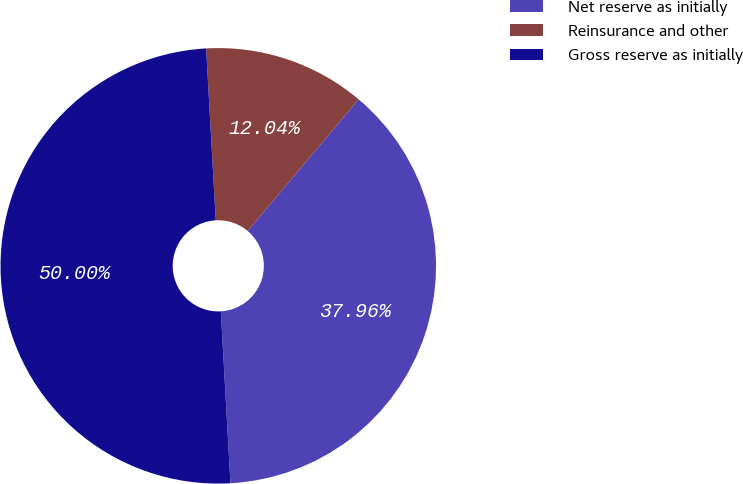Convert chart to OTSL. <chart><loc_0><loc_0><loc_500><loc_500><pie_chart><fcel>Net reserve as initially<fcel>Reinsurance and other<fcel>Gross reserve as initially<nl><fcel>37.96%<fcel>12.04%<fcel>50.0%<nl></chart> 